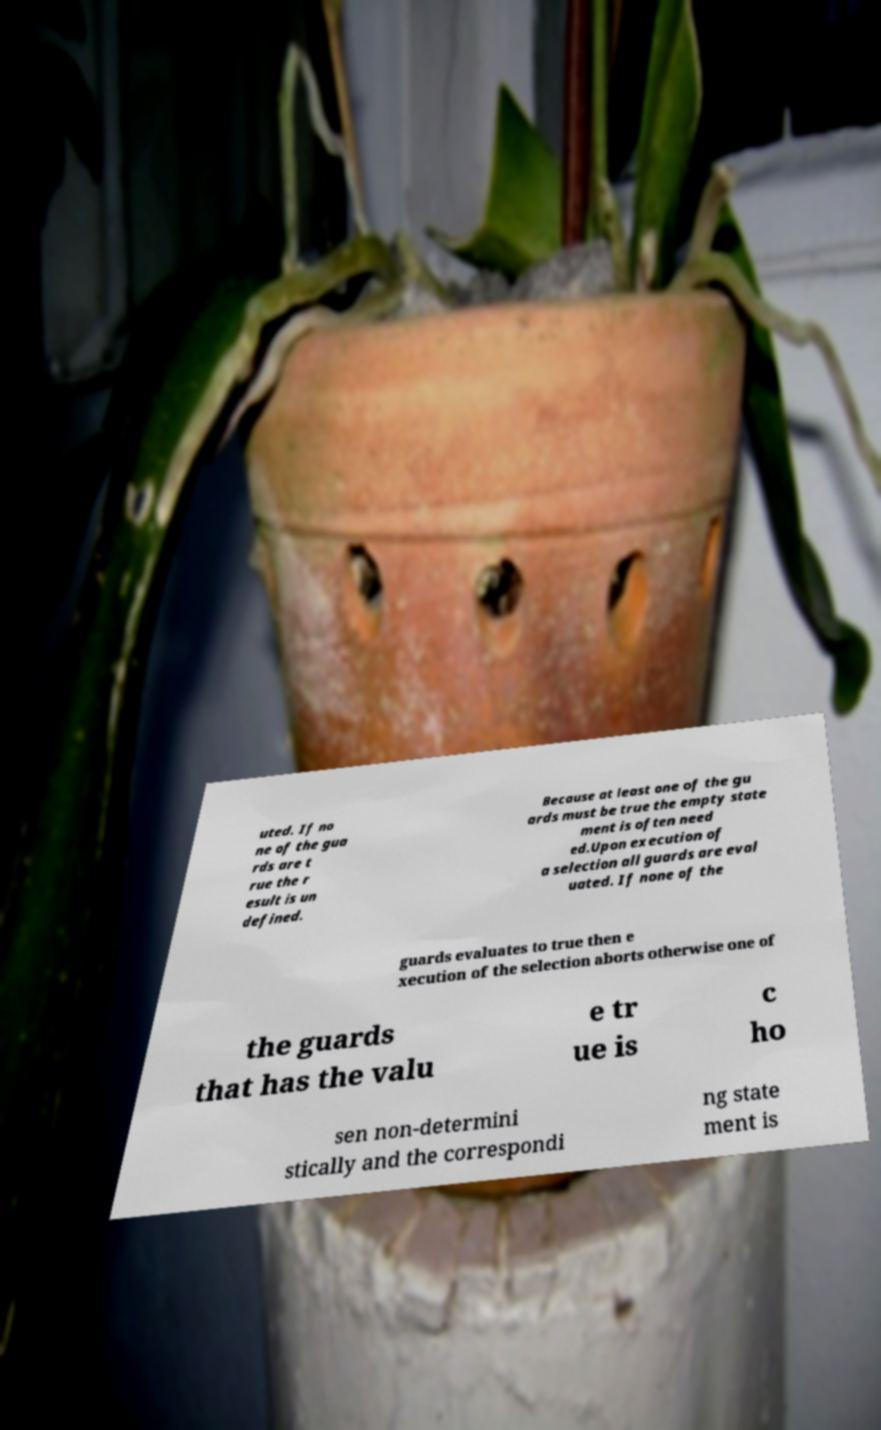Can you read and provide the text displayed in the image?This photo seems to have some interesting text. Can you extract and type it out for me? uted. If no ne of the gua rds are t rue the r esult is un defined. Because at least one of the gu ards must be true the empty state ment is often need ed.Upon execution of a selection all guards are eval uated. If none of the guards evaluates to true then e xecution of the selection aborts otherwise one of the guards that has the valu e tr ue is c ho sen non-determini stically and the correspondi ng state ment is 